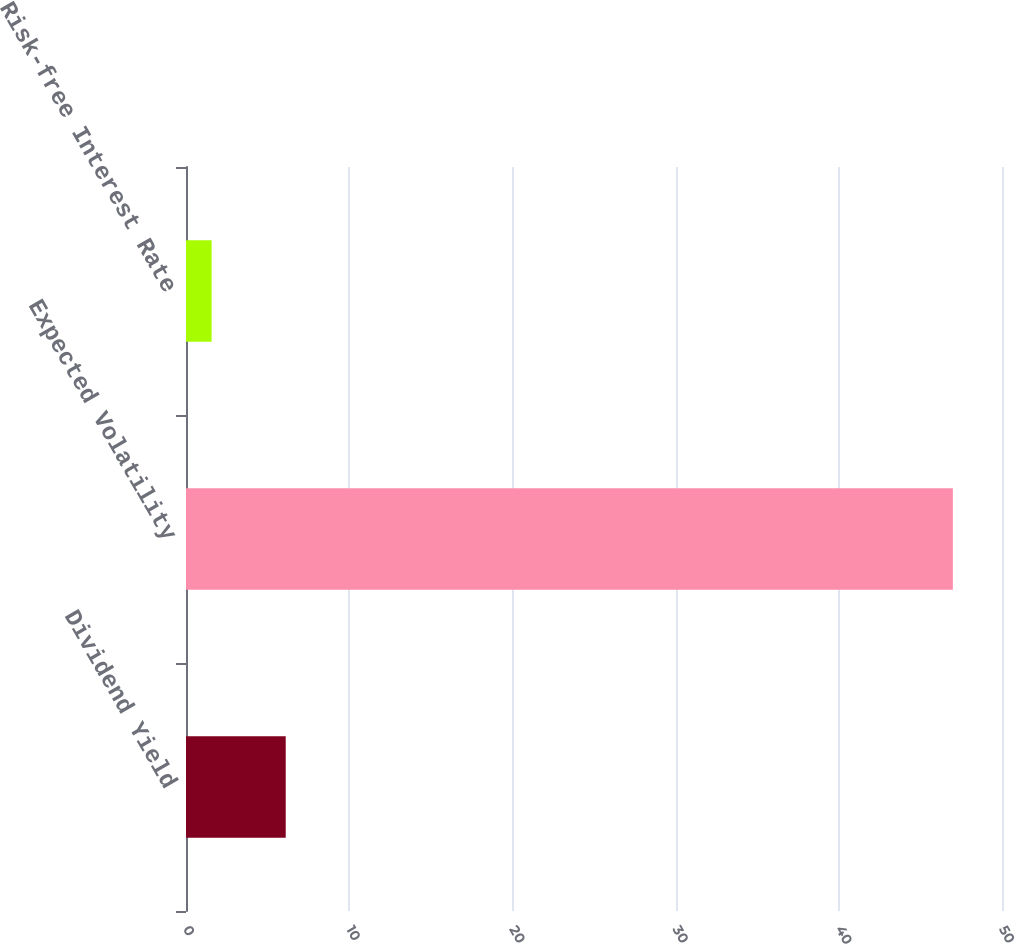<chart> <loc_0><loc_0><loc_500><loc_500><bar_chart><fcel>Dividend Yield<fcel>Expected Volatility<fcel>Risk-free Interest Rate<nl><fcel>6.11<fcel>46.99<fcel>1.57<nl></chart> 